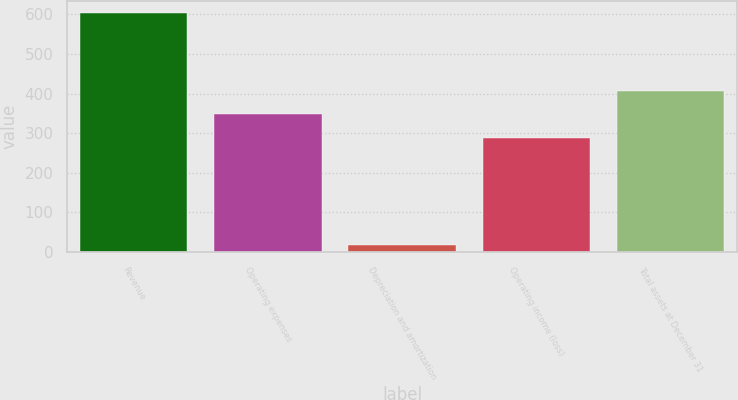Convert chart to OTSL. <chart><loc_0><loc_0><loc_500><loc_500><bar_chart><fcel>Revenue<fcel>Operating expenses<fcel>Depreciation and amortization<fcel>Operating income (loss)<fcel>Total assets at December 31<nl><fcel>602.3<fcel>347.07<fcel>16.6<fcel>288.5<fcel>405.64<nl></chart> 